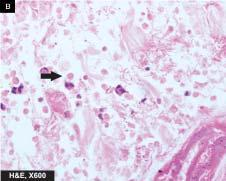re trophozoites of entamoeba histolytica seen at the margin of ulcer?
Answer the question using a single word or phrase. Yes 